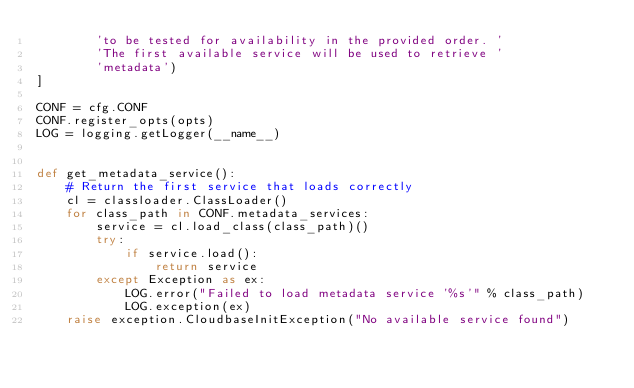<code> <loc_0><loc_0><loc_500><loc_500><_Python_>        'to be tested for availability in the provided order. '
        'The first available service will be used to retrieve '
        'metadata')
]

CONF = cfg.CONF
CONF.register_opts(opts)
LOG = logging.getLogger(__name__)


def get_metadata_service():
    # Return the first service that loads correctly
    cl = classloader.ClassLoader()
    for class_path in CONF.metadata_services:
        service = cl.load_class(class_path)()
        try:
            if service.load():
                return service
        except Exception as ex:
            LOG.error("Failed to load metadata service '%s'" % class_path)
            LOG.exception(ex)
    raise exception.CloudbaseInitException("No available service found")
</code> 